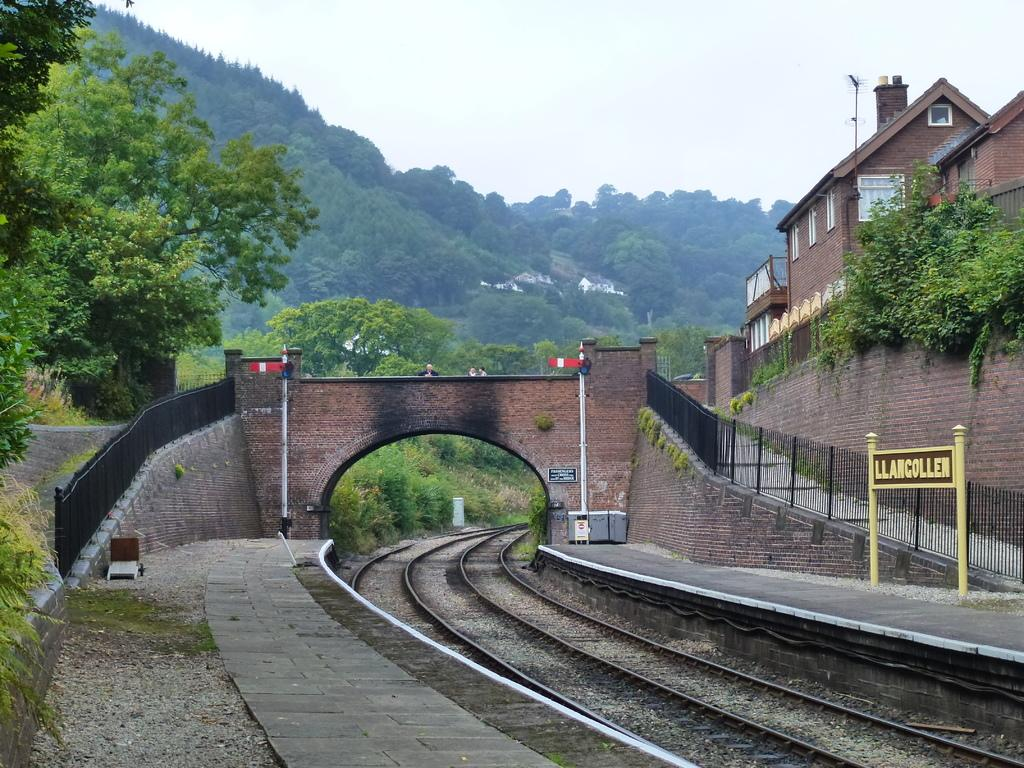<image>
Relay a brief, clear account of the picture shown. A railway track and bridge and a sign reading Llancollen 